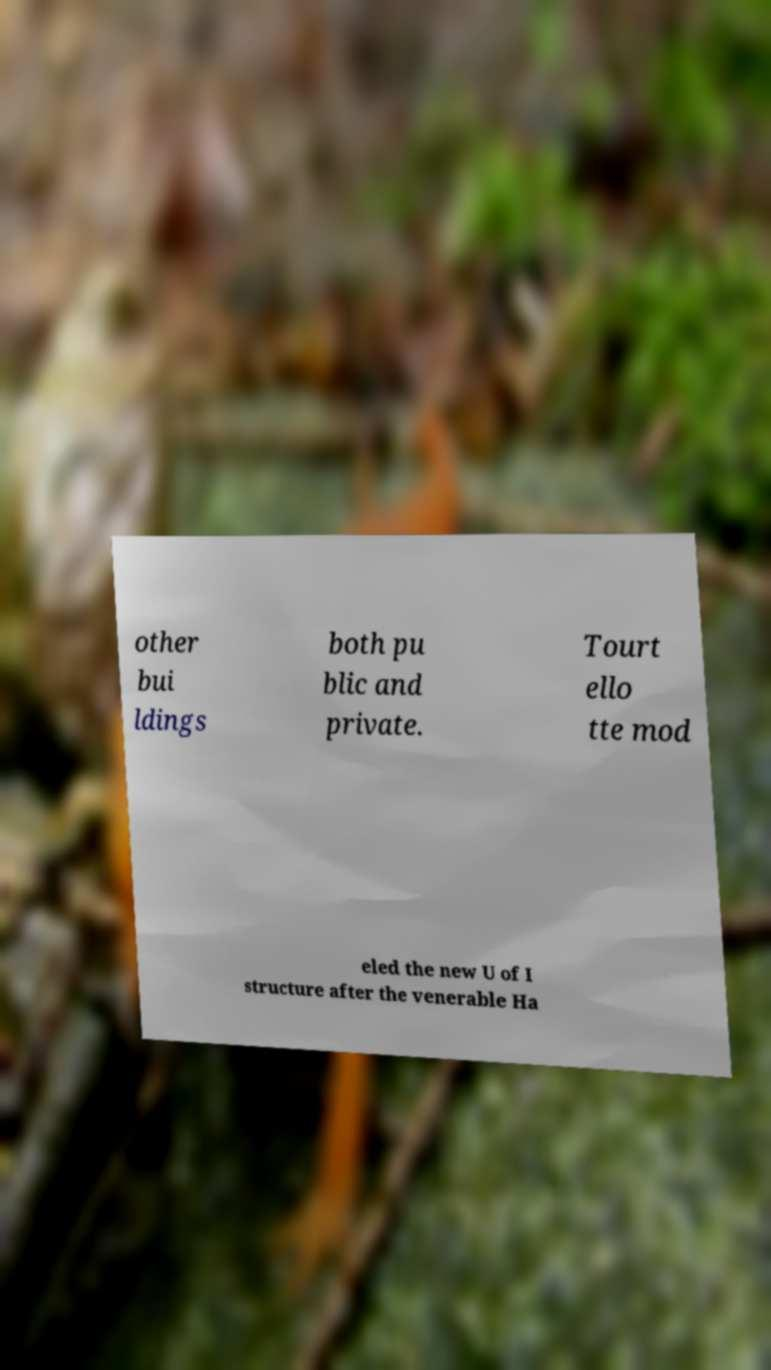Please identify and transcribe the text found in this image. other bui ldings both pu blic and private. Tourt ello tte mod eled the new U of I structure after the venerable Ha 